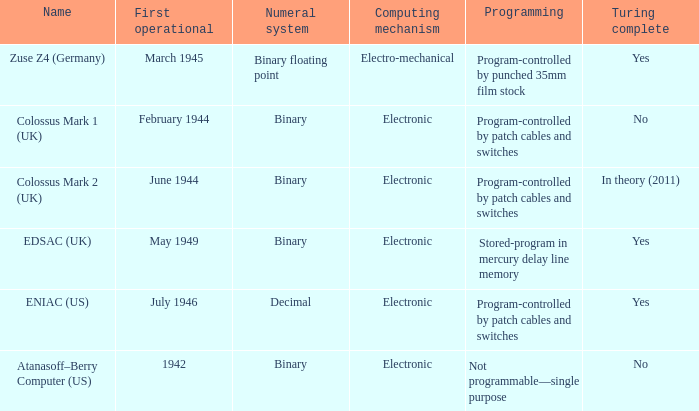What's the computing mechanbeingm with name being atanasoff–berry computer (us) Electronic. 